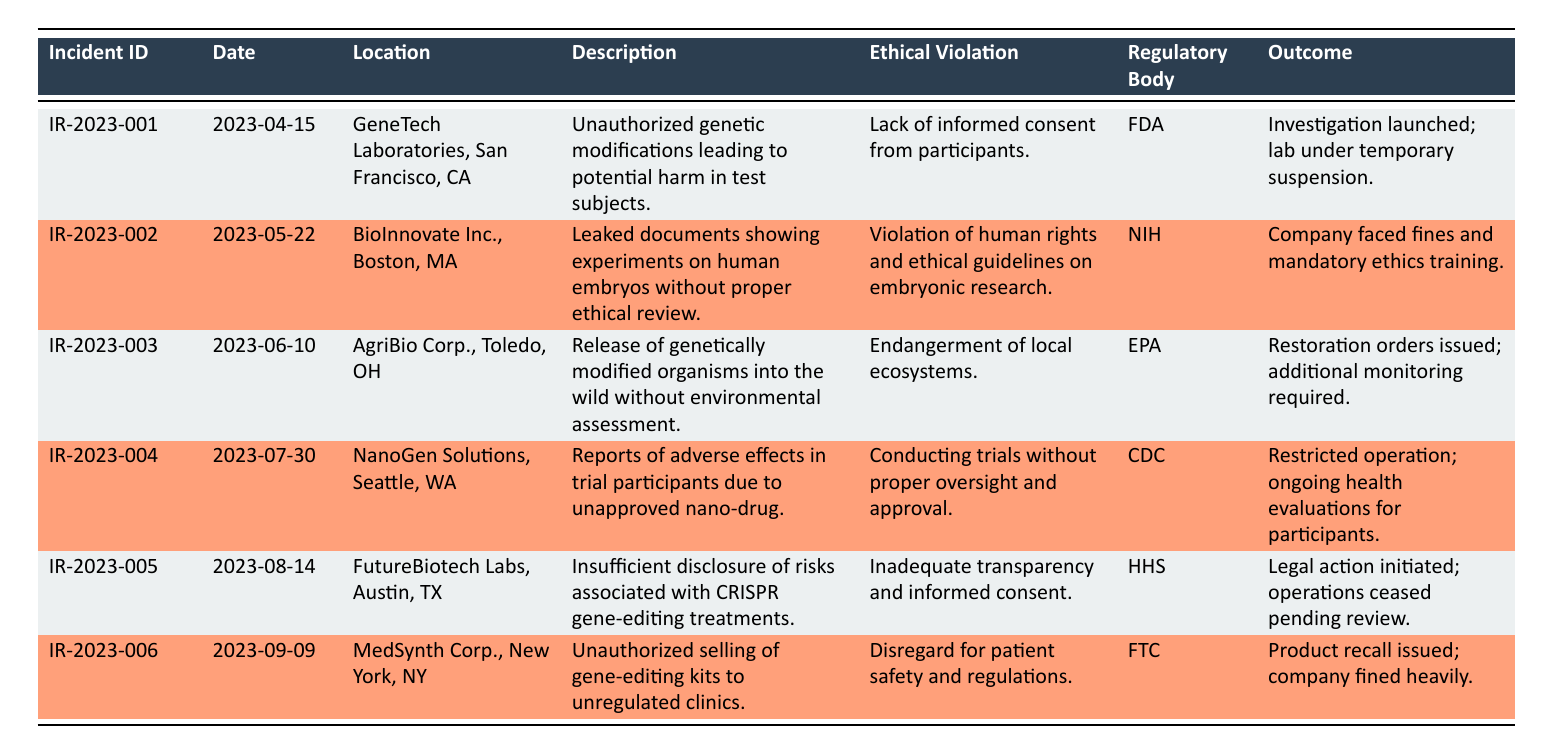What is the date of the incident involving GeneTech Laboratories? The date can be found directly in the row corresponding to GeneTech Laboratories. It states that the incident occurred on April 15, 2023.
Answer: April 15, 2023 How many incidents are reported in total? By counting each entry in the table, we can determine that there are six incidents listed in total.
Answer: 6 What ethical violation was reported in connection with the incident at BioInnovate Inc.? The ethical violation for BioInnovate Inc. is listed specifically as the "Violation of human rights and ethical guidelines on embryonic research" in the corresponding row.
Answer: Violation of human rights and ethical guidelines on embryonic research Which regulatory body handled the incident related to MedSynth Corp.? From the table, we see that the regulatory body overseeing the MedSynth Corp. incident is the FTC, as noted in the relevant row.
Answer: FTC How many incidents involved a lack of informed consent? Analyzing the table, we identify that there is one incident regarding a lack of informed consent, which is associated with GeneTech Laboratories alone.
Answer: 1 Is there an incident outcome listed for NanoGen Solutions? Yes, the outcome for NanoGen Solutions is provided as "Restricted operation; ongoing health evaluations for participants."
Answer: Yes What was the outcome of the incident involving FutureBiotech Labs? The outcome of the FutureBiotech Labs incident is summarized in the table as "Legal action initiated; operations ceased pending review."
Answer: Legal action initiated; operations ceased pending review Among all the incidents, how many involved fines? Upon reviewing the table, we find that two incidents led to fines: the one associated with BioInnovate Inc. and the one with MedSynth Corp. as noted in their respective outcomes.
Answer: 2 Which location had an incident due to unapproved experimentation on human embryos? The incident tied to unapproved experiments on human embryos occurred at BioInnovate Inc. in Boston, MA, as stated in the description.
Answer: BioInnovate Inc., Boston, MA 